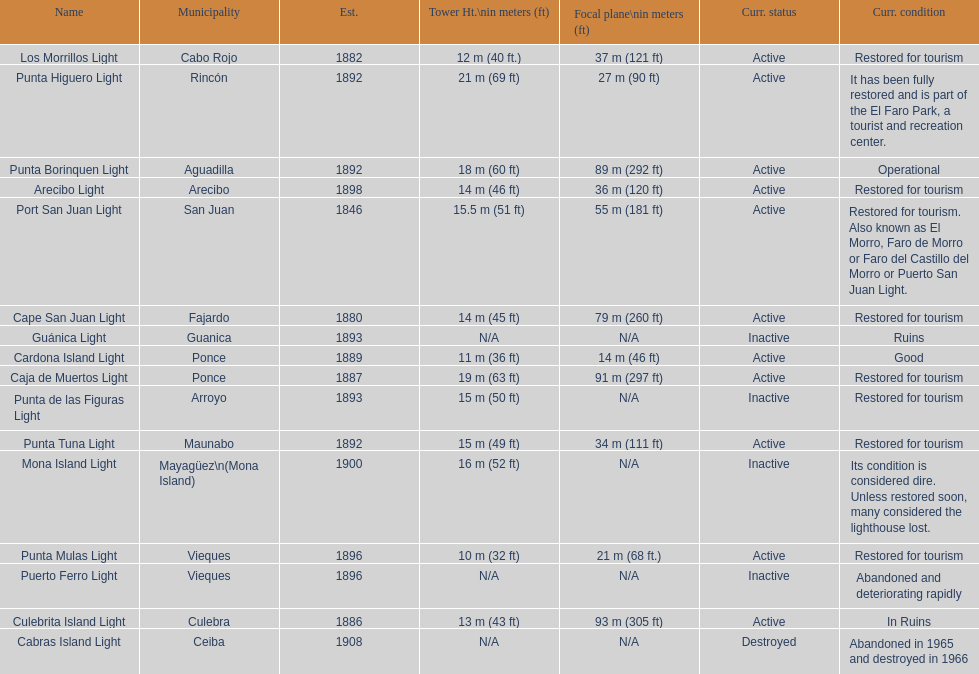What is the duration in years between 1882 and 1889? 7. 